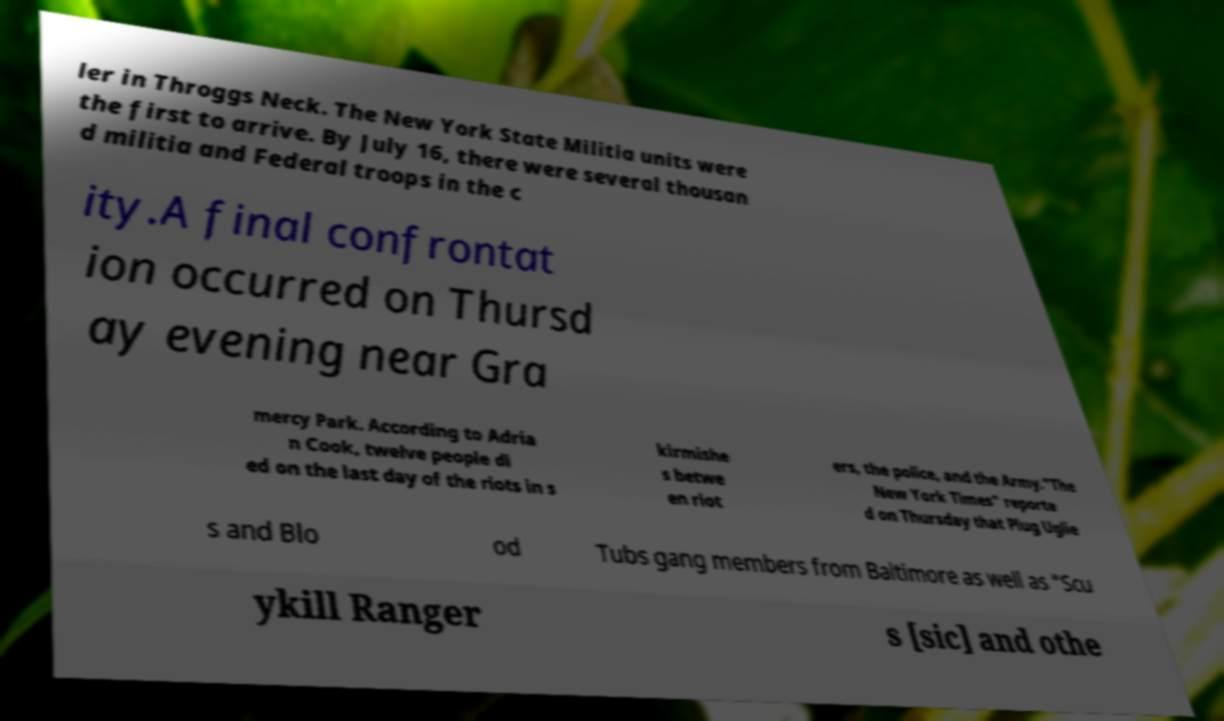Could you assist in decoding the text presented in this image and type it out clearly? ler in Throggs Neck. The New York State Militia units were the first to arrive. By July 16, there were several thousan d militia and Federal troops in the c ity.A final confrontat ion occurred on Thursd ay evening near Gra mercy Park. According to Adria n Cook, twelve people di ed on the last day of the riots in s kirmishe s betwe en riot ers, the police, and the Army."The New York Times" reporte d on Thursday that Plug Uglie s and Blo od Tubs gang members from Baltimore as well as "Scu ykill Ranger s [sic] and othe 